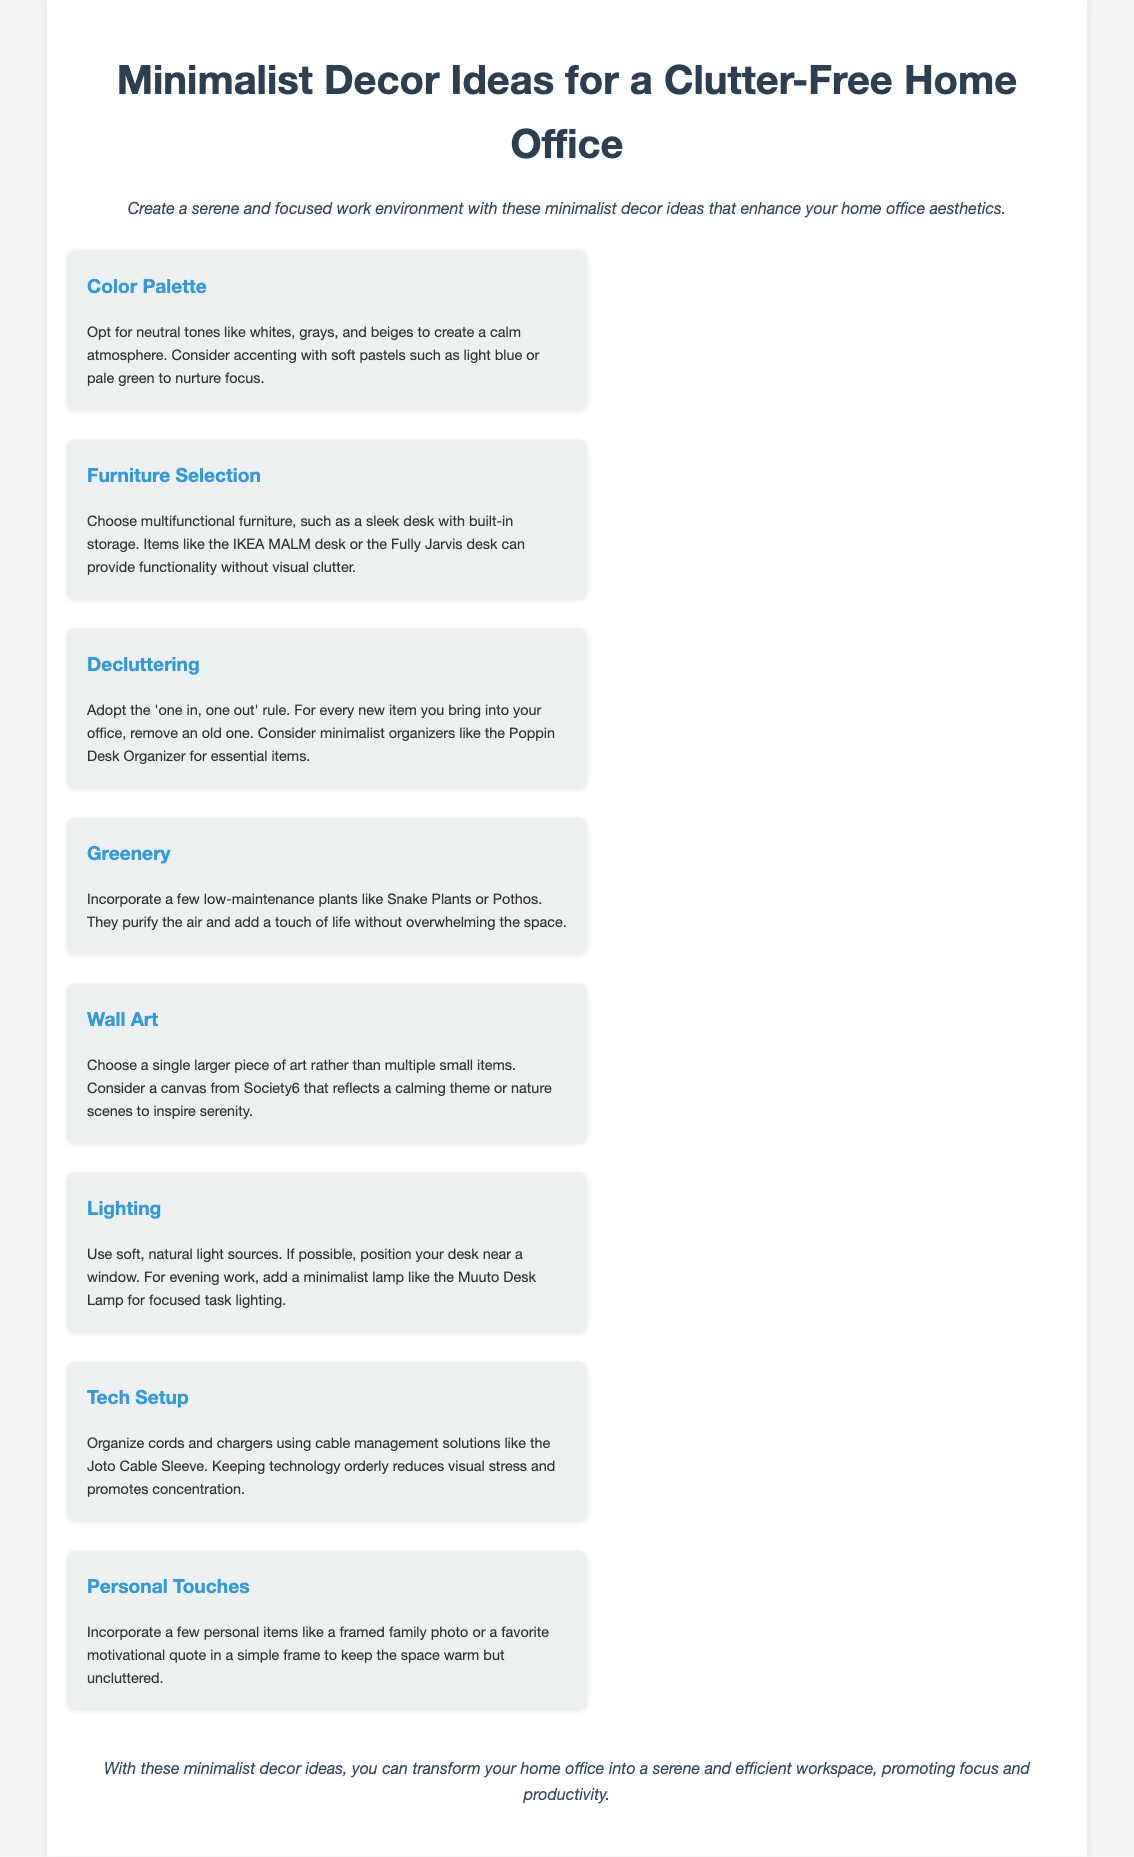what color palette is suggested? The suggested color palette includes neutral tones like whites, grays, and beiges, with accents of soft pastels such as light blue or pale green.
Answer: neutral tones, soft pastels which furniture model is mentioned as multifunctional? The document mentions the IKEA MALM desk and the Fully Jarvis desk as examples of multifunctional furniture.
Answer: IKEA MALM desk, Fully Jarvis desk what rule is recommended for decluttering? The recommended rule for decluttering is the 'one in, one out' rule.
Answer: one in, one out which plants are suggested for incorporating greenery? Low-maintenance plants like Snake Plants or Pothos are suggested for incorporating greenery.
Answer: Snake Plants, Pothos how should wall art be selected? The document advises to choose a single larger piece of art rather than multiple small items.
Answer: single larger piece what type of lighting is recommended for the workspace? Soft, natural light sources are recommended for the workspace.
Answer: soft, natural light what should be used for cord organization? The Joto Cable Sleeve is suggested for organizing cords and chargers.
Answer: Joto Cable Sleeve how can personal touches be incorporated? The document suggests incorporating a framed family photo or a favorite motivational quote in a simple frame as personal touches.
Answer: framed family photo, motivational quote 